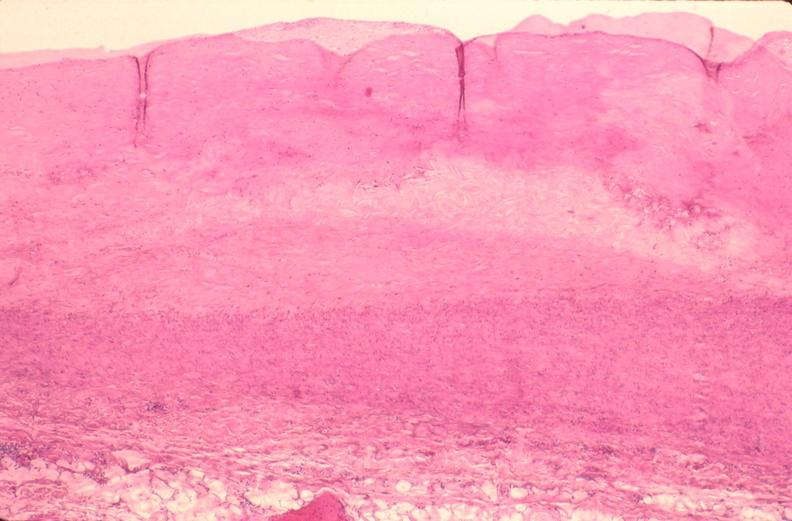s very good example present?
Answer the question using a single word or phrase. No 